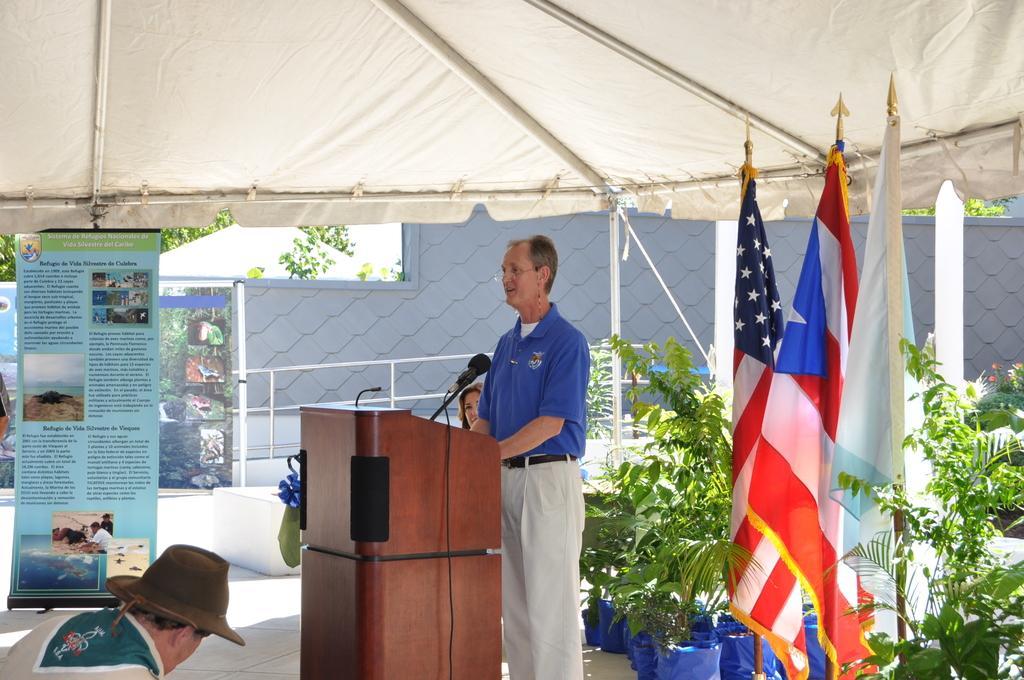How would you summarize this image in a sentence or two? A person is standing wearing a blue t shirt and trousers and there is another person. There is a microphone and its table in front of him. A person is present on the left wearing a hat. There are banners and plants on the right. There is a tent and fence at the back. 